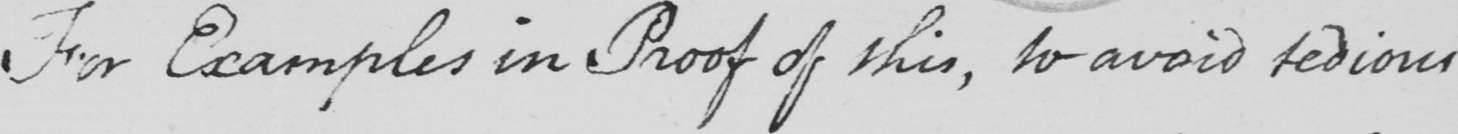Can you tell me what this handwritten text says? For Examples in Proof of this , to avoid tedious 